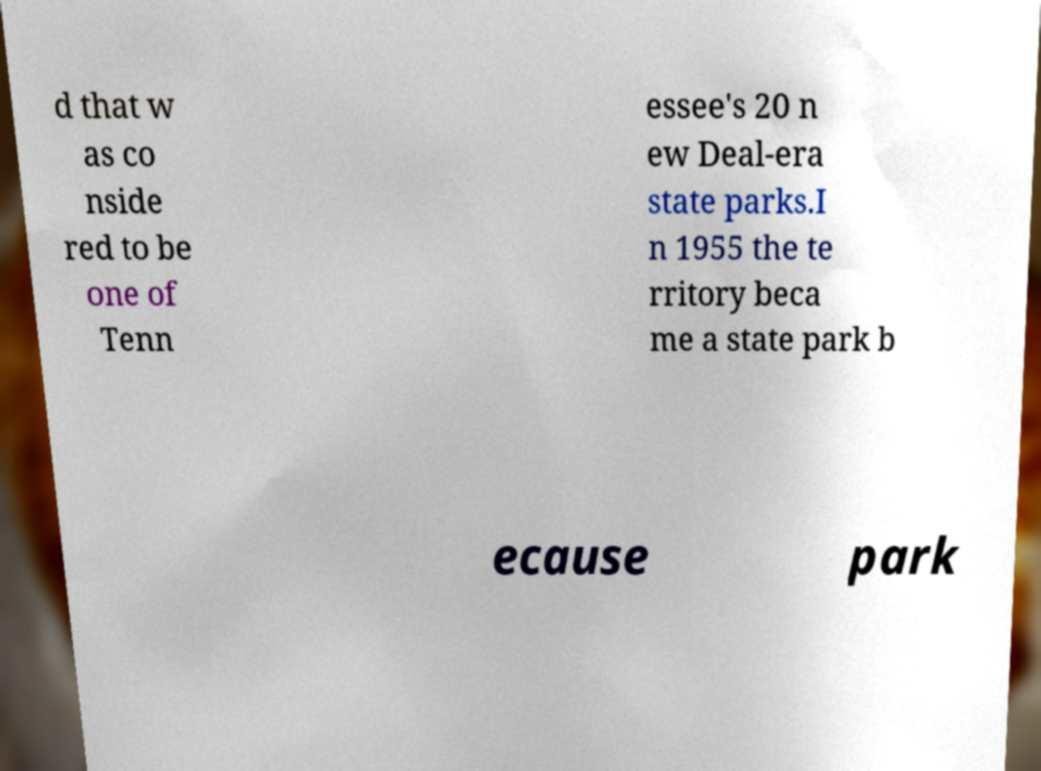For documentation purposes, I need the text within this image transcribed. Could you provide that? d that w as co nside red to be one of Tenn essee's 20 n ew Deal-era state parks.I n 1955 the te rritory beca me a state park b ecause park 